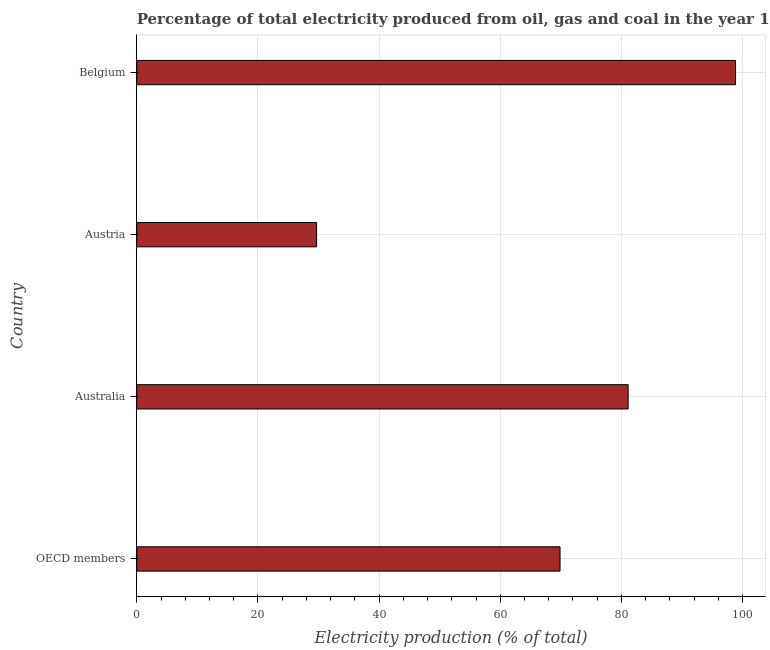Does the graph contain any zero values?
Ensure brevity in your answer.  No. Does the graph contain grids?
Give a very brief answer. Yes. What is the title of the graph?
Your answer should be compact. Percentage of total electricity produced from oil, gas and coal in the year 1968. What is the label or title of the X-axis?
Provide a short and direct response. Electricity production (% of total). What is the electricity production in Austria?
Make the answer very short. 29.68. Across all countries, what is the maximum electricity production?
Your answer should be compact. 98.85. Across all countries, what is the minimum electricity production?
Offer a very short reply. 29.68. What is the sum of the electricity production?
Offer a very short reply. 279.51. What is the difference between the electricity production in Belgium and OECD members?
Keep it short and to the point. 28.97. What is the average electricity production per country?
Offer a terse response. 69.88. What is the median electricity production?
Your response must be concise. 75.49. What is the ratio of the electricity production in Australia to that in OECD members?
Keep it short and to the point. 1.16. What is the difference between the highest and the second highest electricity production?
Your answer should be very brief. 17.74. Is the sum of the electricity production in Australia and OECD members greater than the maximum electricity production across all countries?
Offer a very short reply. Yes. What is the difference between the highest and the lowest electricity production?
Your answer should be very brief. 69.16. How many bars are there?
Keep it short and to the point. 4. What is the difference between two consecutive major ticks on the X-axis?
Provide a succinct answer. 20. What is the Electricity production (% of total) in OECD members?
Give a very brief answer. 69.87. What is the Electricity production (% of total) in Australia?
Your response must be concise. 81.11. What is the Electricity production (% of total) of Austria?
Give a very brief answer. 29.68. What is the Electricity production (% of total) in Belgium?
Give a very brief answer. 98.85. What is the difference between the Electricity production (% of total) in OECD members and Australia?
Offer a very short reply. -11.24. What is the difference between the Electricity production (% of total) in OECD members and Austria?
Ensure brevity in your answer.  40.19. What is the difference between the Electricity production (% of total) in OECD members and Belgium?
Offer a terse response. -28.97. What is the difference between the Electricity production (% of total) in Australia and Austria?
Offer a terse response. 51.43. What is the difference between the Electricity production (% of total) in Australia and Belgium?
Your answer should be compact. -17.74. What is the difference between the Electricity production (% of total) in Austria and Belgium?
Provide a succinct answer. -69.16. What is the ratio of the Electricity production (% of total) in OECD members to that in Australia?
Your answer should be very brief. 0.86. What is the ratio of the Electricity production (% of total) in OECD members to that in Austria?
Offer a very short reply. 2.35. What is the ratio of the Electricity production (% of total) in OECD members to that in Belgium?
Offer a terse response. 0.71. What is the ratio of the Electricity production (% of total) in Australia to that in Austria?
Offer a very short reply. 2.73. What is the ratio of the Electricity production (% of total) in Australia to that in Belgium?
Your answer should be compact. 0.82. What is the ratio of the Electricity production (% of total) in Austria to that in Belgium?
Your response must be concise. 0.3. 